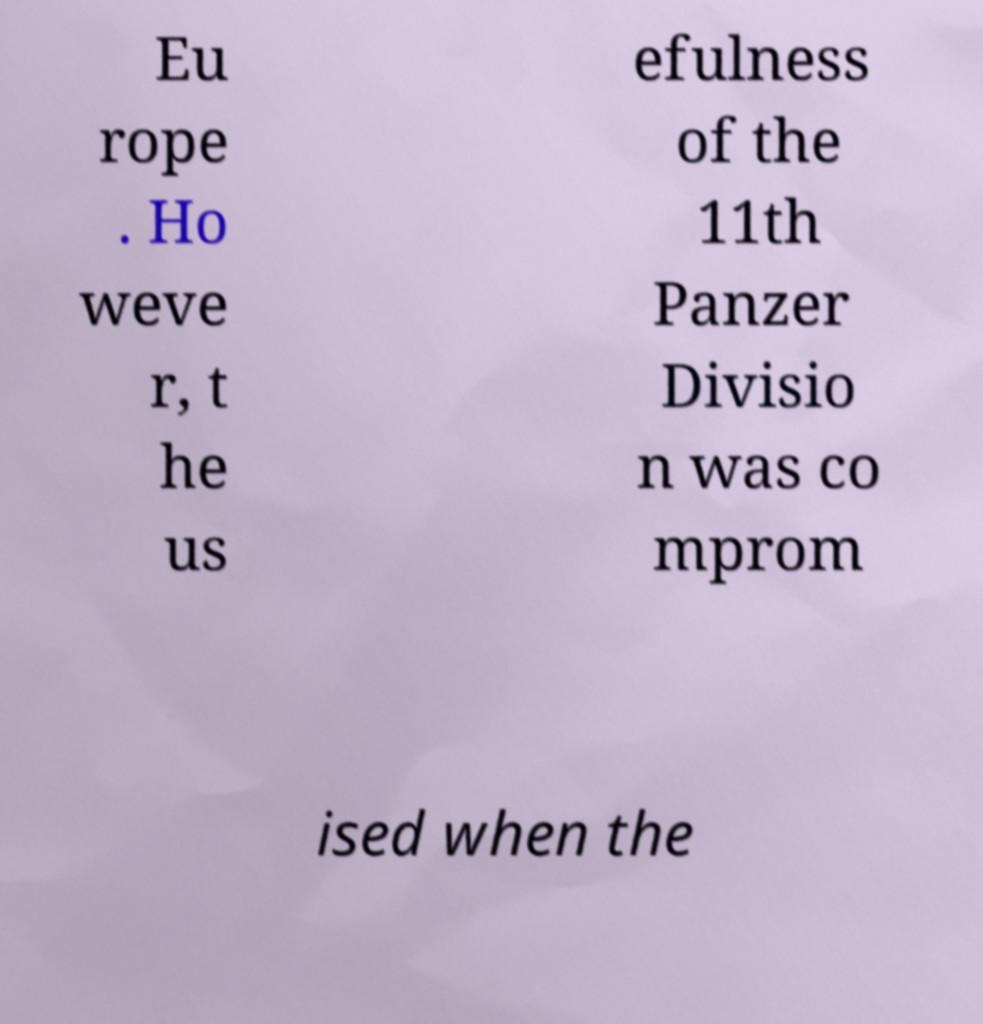What messages or text are displayed in this image? I need them in a readable, typed format. Eu rope . Ho weve r, t he us efulness of the 11th Panzer Divisio n was co mprom ised when the 